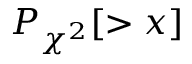Convert formula to latex. <formula><loc_0><loc_0><loc_500><loc_500>P _ { \chi ^ { 2 } } [ > x ]</formula> 